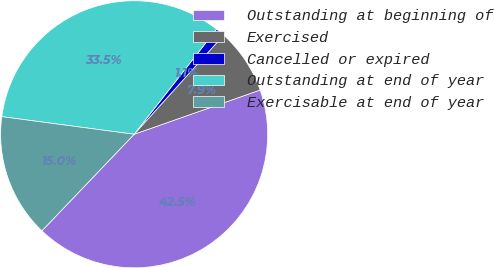Convert chart. <chart><loc_0><loc_0><loc_500><loc_500><pie_chart><fcel>Outstanding at beginning of<fcel>Exercised<fcel>Cancelled or expired<fcel>Outstanding at end of year<fcel>Exercisable at end of year<nl><fcel>42.51%<fcel>7.94%<fcel>1.1%<fcel>33.48%<fcel>14.97%<nl></chart> 